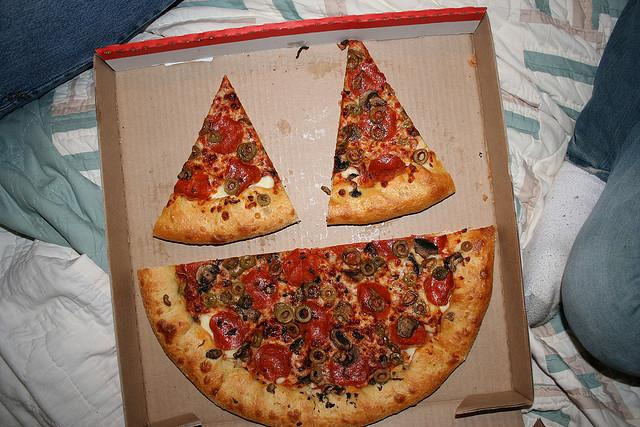Which topping contains the highest level of sodium?

Choices:
A) cheese
B) olive
C) pepperoni
D) mushroom pepperoni 